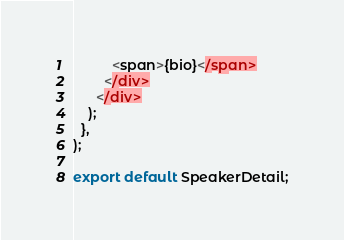Convert code to text. <code><loc_0><loc_0><loc_500><loc_500><_JavaScript_>
          <span>{bio}</span>
        </div>
      </div>
    );
  },
);

export default SpeakerDetail;
</code> 